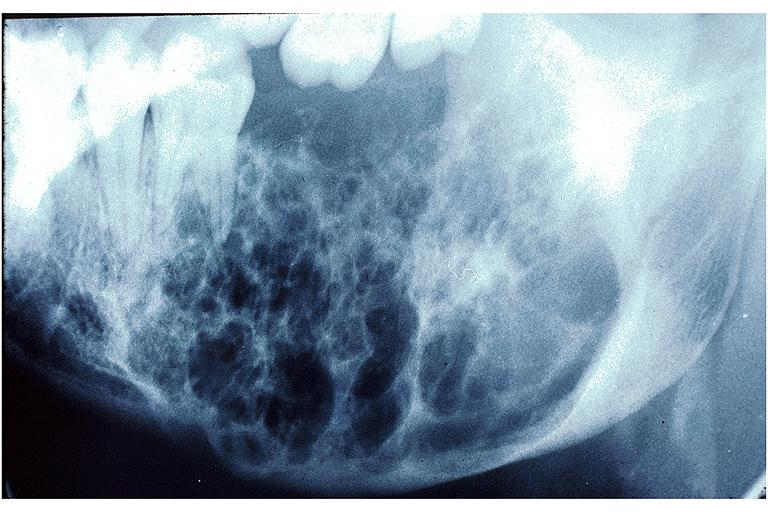does this image show ameloblastoma?
Answer the question using a single word or phrase. Yes 